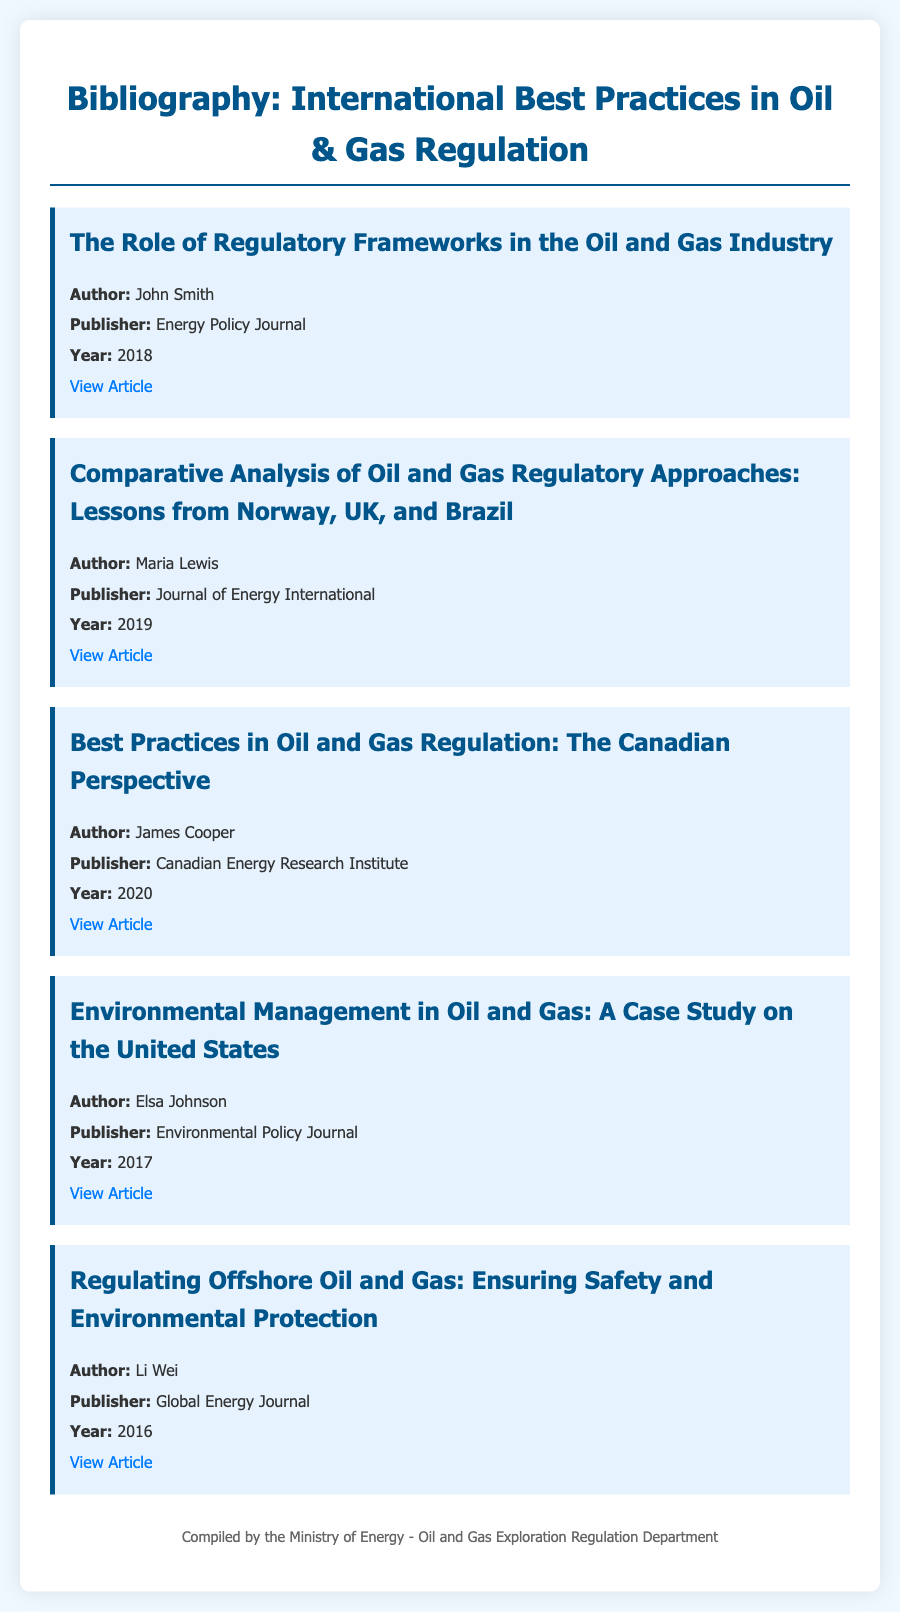What is the title of the first article? The first article is titled "The Role of Regulatory Frameworks in the Oil and Gas Industry."
Answer: The Role of Regulatory Frameworks in the Oil and Gas Industry Who is the author of the article on Canadian best practices? The article on Canadian best practices is authored by James Cooper.
Answer: James Cooper In what year was the article on environmental management published? The article on environmental management was published in 2017.
Answer: 2017 Which journal published the article about regulating offshore oil and gas? The article about regulating offshore oil and gas was published by Global Energy Journal.
Answer: Global Energy Journal How many articles are included in the bibliography? The bibliography includes a total of five articles.
Answer: Five What common theme is highlighted in the second and third articles? Both articles focus on comparative analyses and best practices in oil and gas regulation.
Answer: Comparative analyses and best practices What is the primary focus of the article by Li Wei? The article by Li Wei focuses on safety and environmental protection in offshore oil and gas regulation.
Answer: Safety and environmental protection Which article discusses lessons from Norway, UK, and Brazil? The article that discusses lessons from Norway, UK, and Brazil is titled "Comparative Analysis of Oil and Gas Regulatory Approaches: Lessons from Norway, UK, and Brazil."
Answer: Comparative Analysis of Oil and Gas Regulatory Approaches: Lessons from Norway, UK, and Brazil Who compiled the document? The document was compiled by the Ministry of Energy - Oil and Gas Exploration Regulation Department.
Answer: Ministry of Energy - Oil and Gas Exploration Regulation Department 